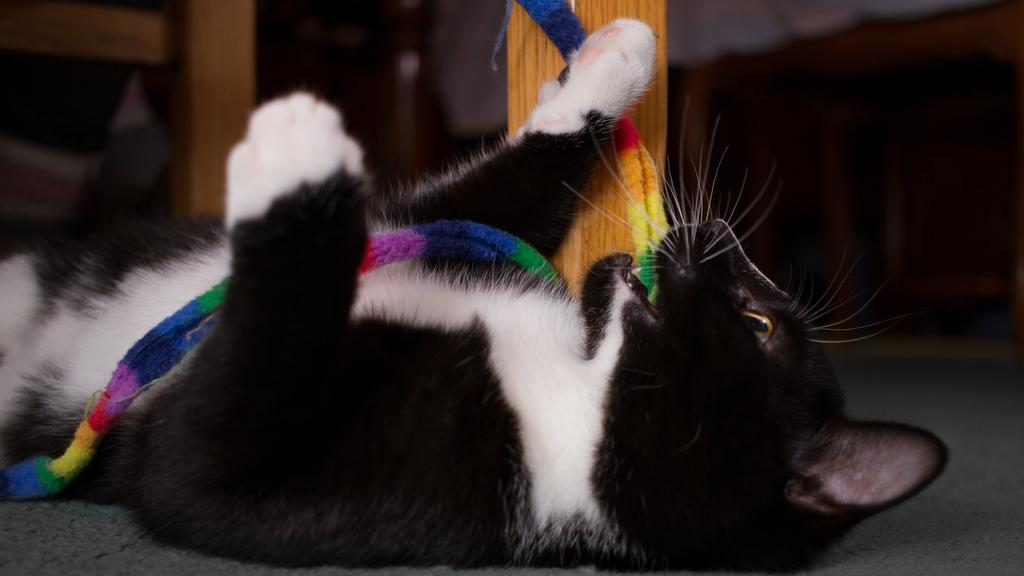What type of animal is on the ground in the image? There is a cat on the ground in the image. What material are some of the objects made of in the image? There are wooden objects in the image. Can you describe any other objects in the image besides the cat and wooden objects? There are other unspecified objects in the image. What type of paint is the cat using to draw on the wooden objects in the image? There is no paint or drawing activity present in the image; the cat is simply on the ground. 